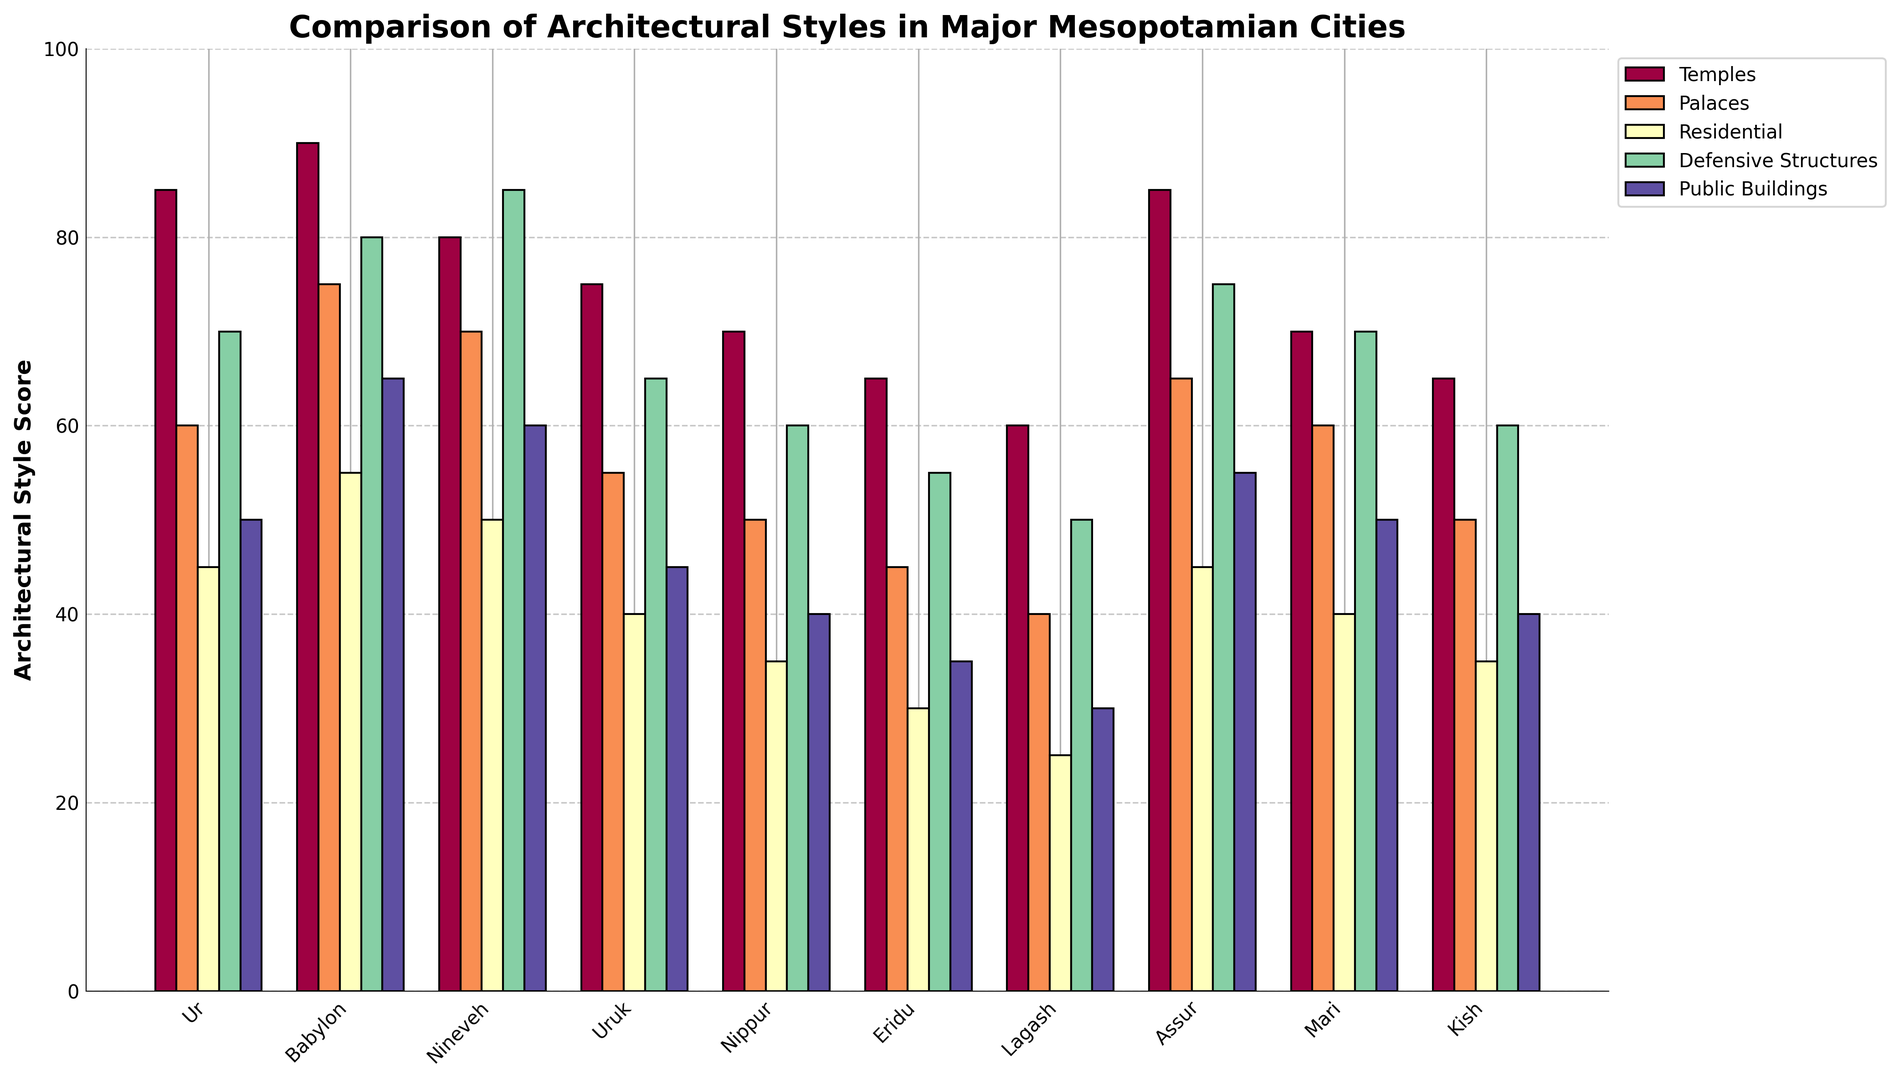What city has the highest score for temples? In the chart, look for the tallest bar in the 'Temples' category. Babylon has the tallest bar for temples.
Answer: Babylon How many categories have a score higher than 70 in Ur? Check the height of the bars for Ur across all building types. Temples, Palaces, and Defensive Structures are higher than 70.
Answer: 3 Compare the score of public buildings between Babylon and Nineveh. Which city has a higher score and by how much? Observe the bars for Public Buildings in Babylon and Nineveh. Babylon has a score of 65, and Nineveh has a score of 60. The difference is 65 - 60.
Answer: Babylon, 5 Which city has the lowest score for residential buildings? Look at the bars in the 'Residential' category and find the shortest one. Lagash has the shortest bar for residential buildings.
Answer: Lagash What is the sum of Palace scores for Uruk and Nippur? Add the Palace scores of Uruk and Nippur. Uruk has 55, and Nippur has 50. 55 + 50 equals 105.
Answer: 105 For which building type does Eridu have the highest score compared to other building types within the same city? Compare the heights of the bars within Eridu across all categories. Temples have the highest score in Eridu.
Answer: Temples What is the average score of Defensive Structures across all cities? Sum up the scores of Defensive Structures for all cities and divide by the number of cities. The sum is 625 and there are 10 cities. 625 / 10 is 62.5.
Answer: 62.5 How does Assur compare to Mari in terms of the scores for palaces and defensive structures combined? Add the Palace and Defensive Structures scores for Assur and Mari. Assur has 65 (palaces) + 75 (defensive structures) = 140. Mari has 60 (palaces) + 70 (defensive structures) = 130.
Answer: Assur has a higher combined score by 10 Which city has the most balanced distribution of scores across all architectural styles? Look for the city with the most evenly distributed heights of bars across all categories. Assur’s bars appear more evenly distributed.
Answer: Assur In which category and city do we see the most variation from the average score in that category? Calculate the average for each category and observe the city with the largest deviation from that average in one category. For example, the average for temples is 74 (sum of all temple scores is 740 / 10), and Eridu deviates the most with its score of 65 (74 - 65 = 9). Repeat for all categories. Highest deviation will be Babylon in defensive structures (average: 69, Babylon: 80, deviation: 11).
Answer: Defensive Structures, Babylon 